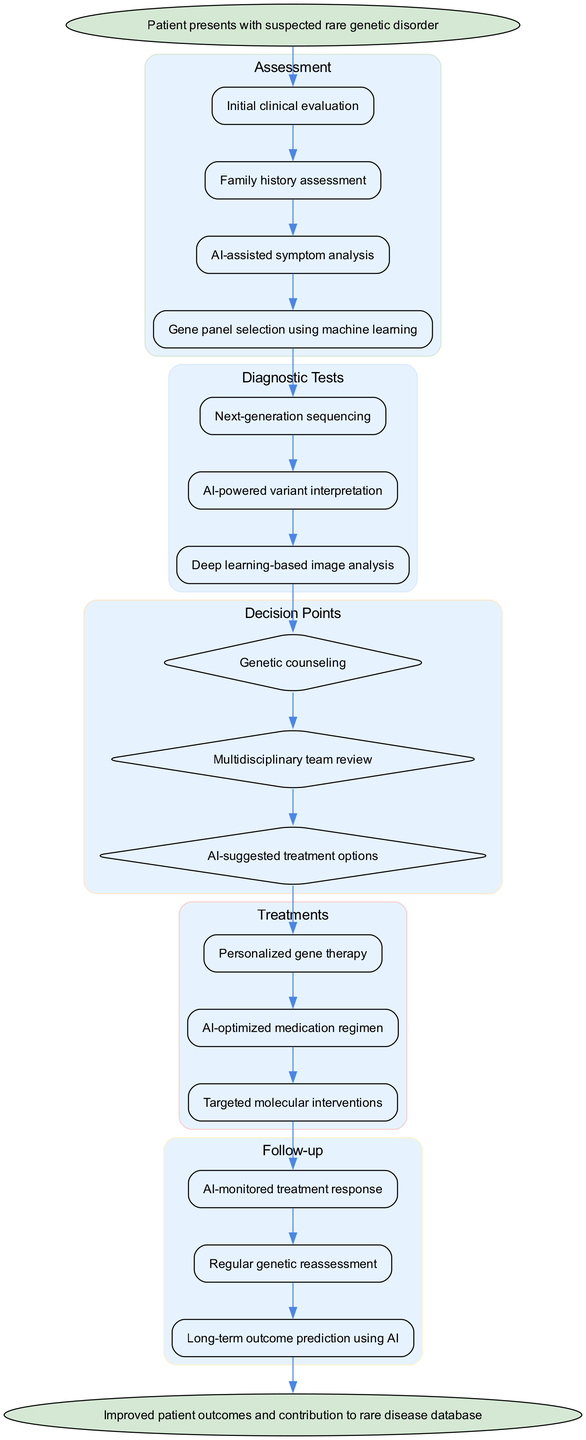What is the starting point of the clinical pathway? The starting point, as indicated by the first node in the diagram, is where the patient presents with a suspected rare genetic disorder.
Answer: Patient presents with suspected rare genetic disorder How many assessment steps are present in the diagram? By counting the nodes within the assessment section of the diagram, I find there are four assessment steps listed.
Answer: 4 What follows after AI-assisted symptom analysis in the pathway? The next node after AI-assisted symptom analysis in the flow of the diagram indicates that the next step is gene panel selection using machine learning.
Answer: Gene panel selection using machine learning Which decision point comes after AI-powered variant interpretation? The decision point that follows AI-powered variant interpretation is genetic counseling, as it is the first decision node after the series of diagnostic tests.
Answer: Genetic counseling How many treatment options are provided in total? Counting the treatment nodes in the treatments section reveals there are three treatment options listed.
Answer: 3 Which treatment follows AI-suggested treatment options in the pathway? The treatment that comes directly after AI-suggested treatment options is personalized gene therapy, as indicated by the flow of treatment nodes.
Answer: Personalized gene therapy What is the outcome aimed for at the end of the pathway? The end point of the pathway is focused on improved patient outcomes and the contribution to a rare disease database, as shown in the final node.
Answer: Improved patient outcomes and contribution to rare disease database What follows the treatment 'AI-optimized medication regimen'? The follow-up node following the treatment 'AI-optimized medication regimen' is AI-monitored treatment response, according to the flow of the path.
Answer: AI-monitored treatment response How many follow-up steps are there in total? By examining the follow-up section of the diagram, I see there are three distinct follow-up steps outlined.
Answer: 3 